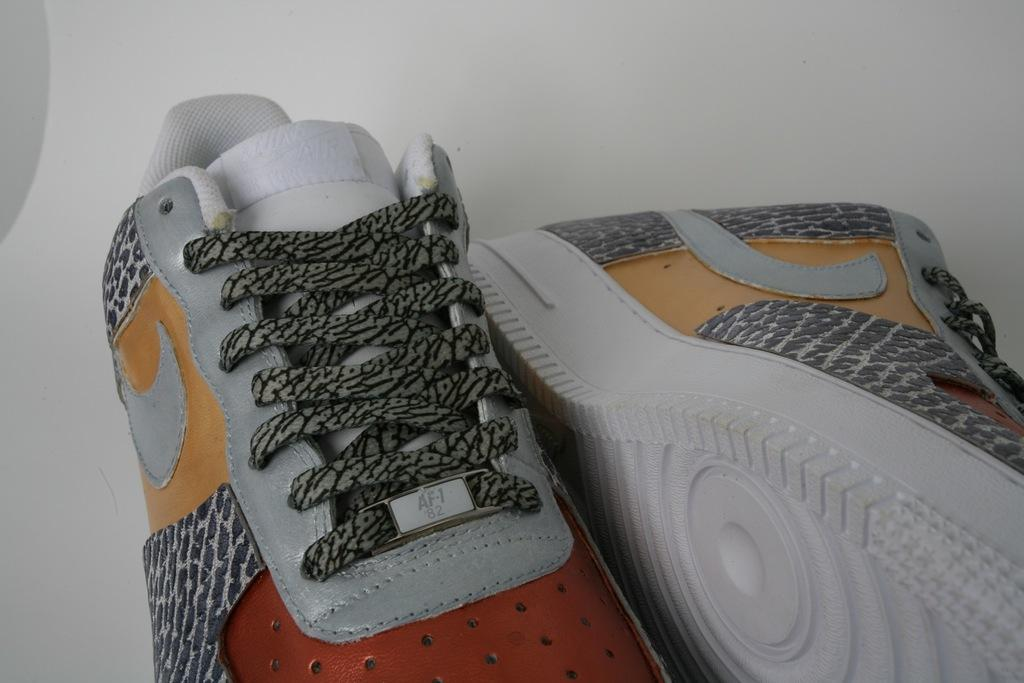What is located in the middle of the image? There is a pair of shoes in the middle of the image. What type of wool can be seen being spun by the geese in the image? There are no geese or wool present in the image; it features a pair of shoes in the middle. What type of linen is used to make the shoes in the image? The image does not provide information about the materials used to make the shoes. 